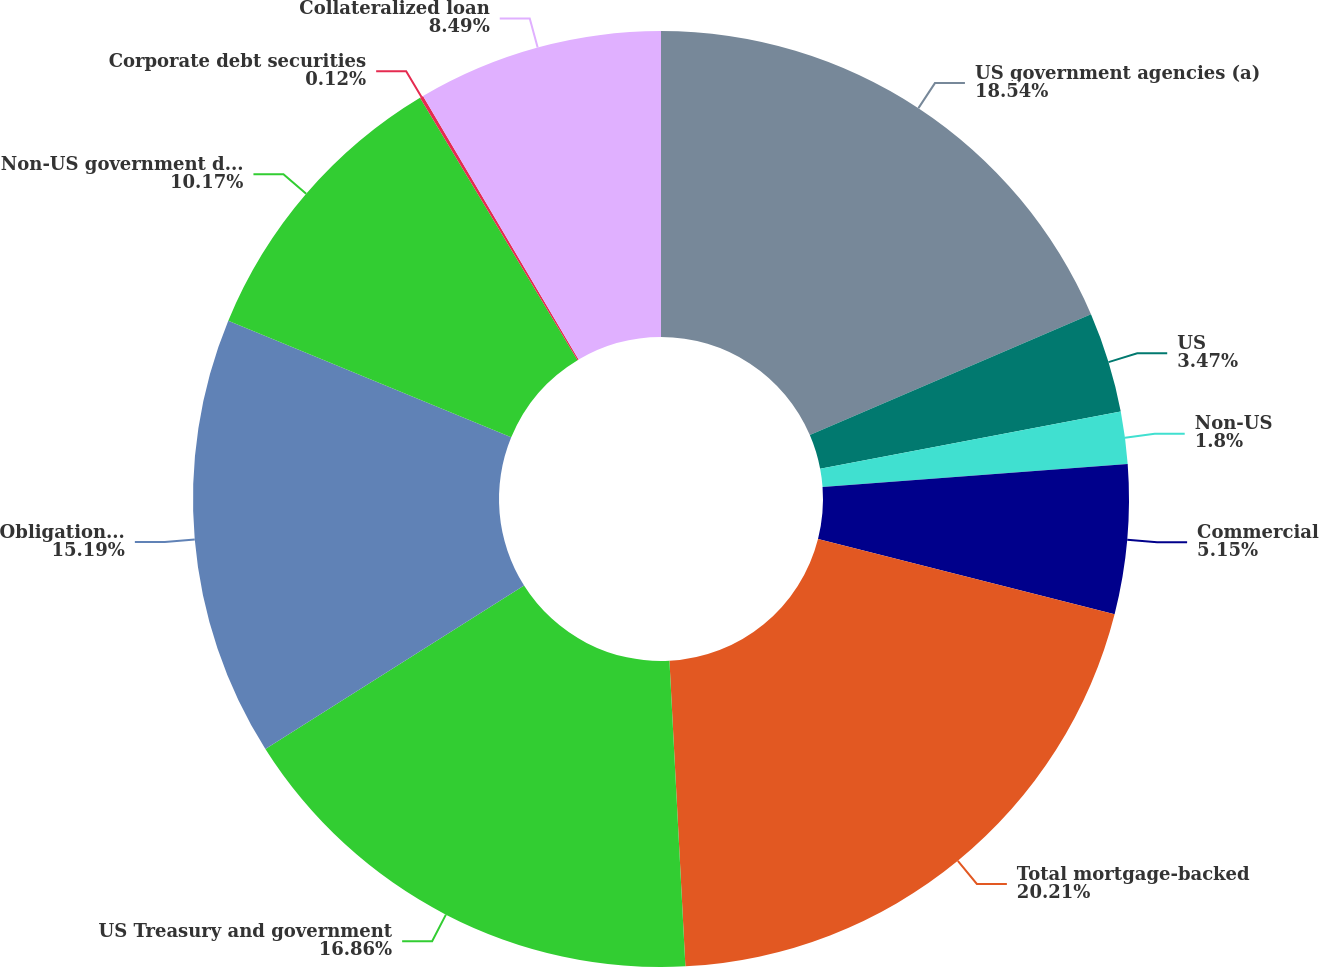Convert chart to OTSL. <chart><loc_0><loc_0><loc_500><loc_500><pie_chart><fcel>US government agencies (a)<fcel>US<fcel>Non-US<fcel>Commercial<fcel>Total mortgage-backed<fcel>US Treasury and government<fcel>Obligations of US states and<fcel>Non-US government debt<fcel>Corporate debt securities<fcel>Collateralized loan<nl><fcel>18.54%<fcel>3.47%<fcel>1.8%<fcel>5.15%<fcel>20.21%<fcel>16.86%<fcel>15.19%<fcel>10.17%<fcel>0.12%<fcel>8.49%<nl></chart> 